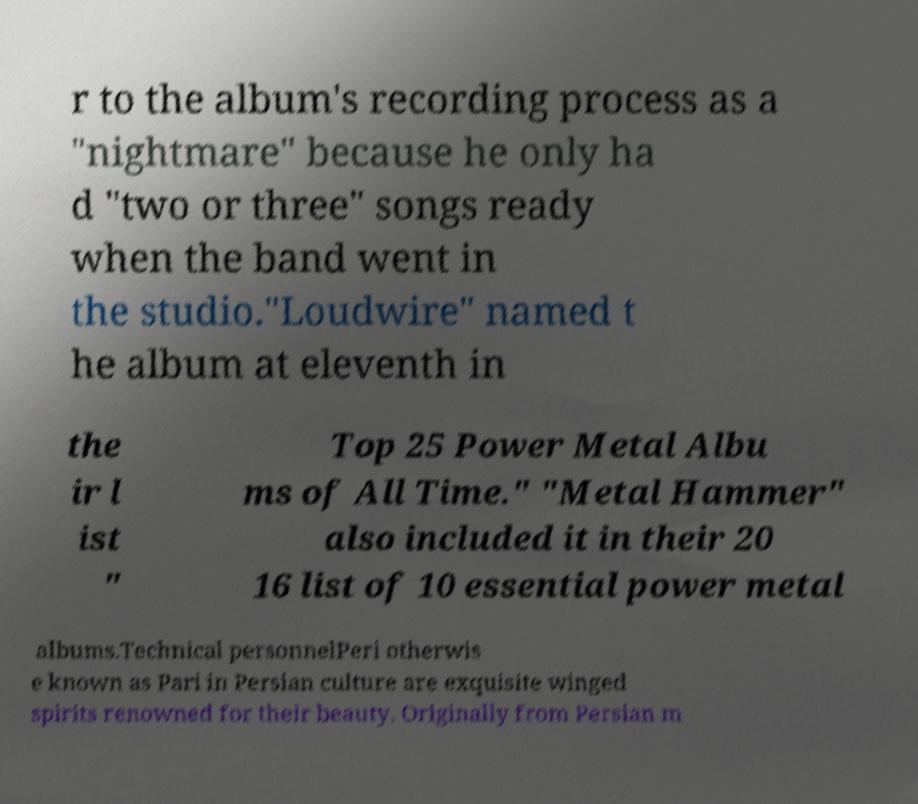Could you assist in decoding the text presented in this image and type it out clearly? r to the album's recording process as a "nightmare" because he only ha d "two or three" songs ready when the band went in the studio."Loudwire" named t he album at eleventh in the ir l ist " Top 25 Power Metal Albu ms of All Time." "Metal Hammer" also included it in their 20 16 list of 10 essential power metal albums.Technical personnelPeri otherwis e known as Pari in Persian culture are exquisite winged spirits renowned for their beauty. Originally from Persian m 